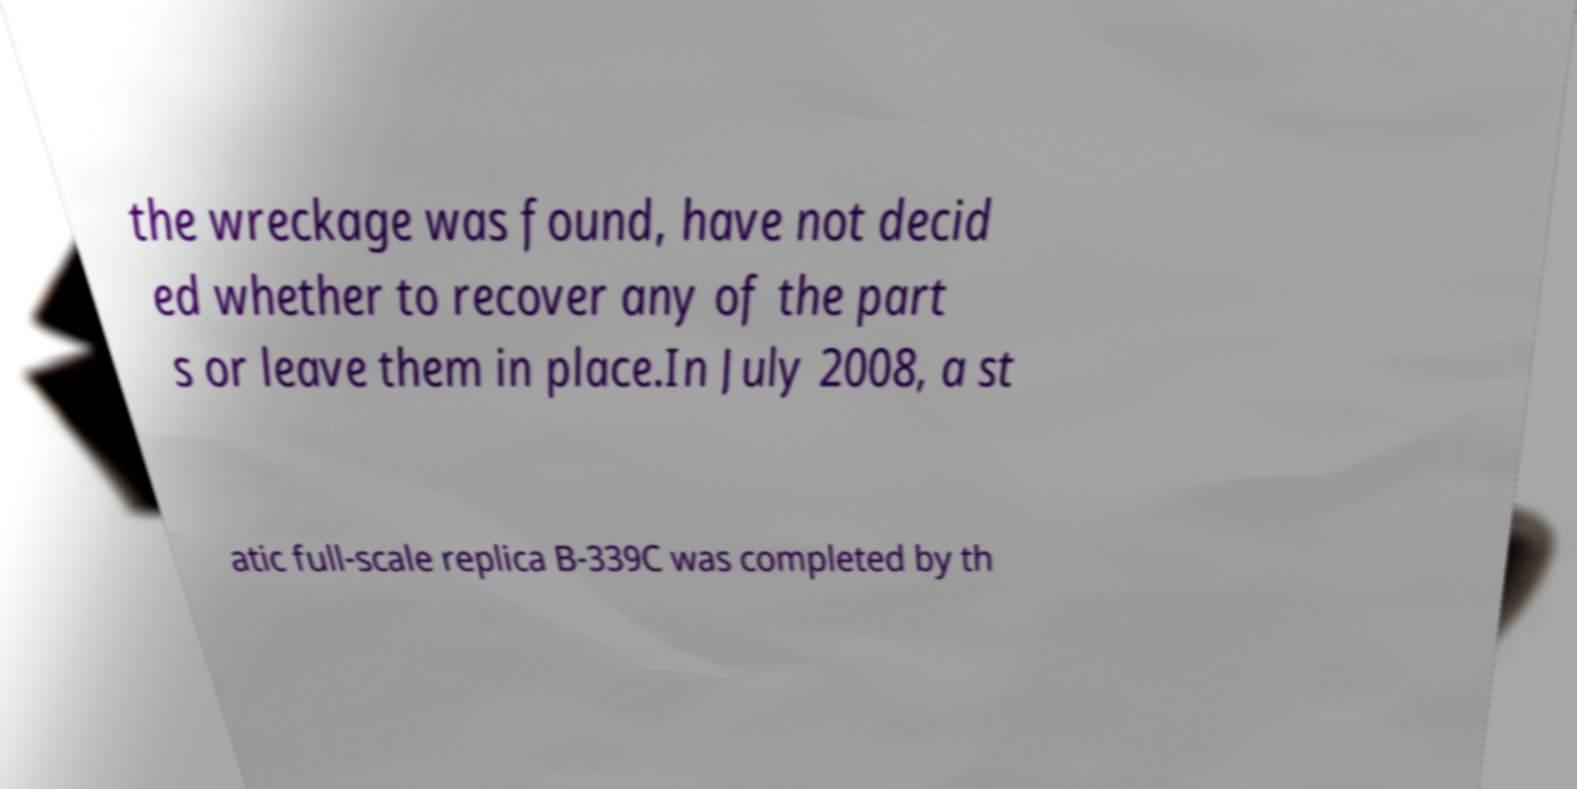What messages or text are displayed in this image? I need them in a readable, typed format. the wreckage was found, have not decid ed whether to recover any of the part s or leave them in place.In July 2008, a st atic full-scale replica B-339C was completed by th 